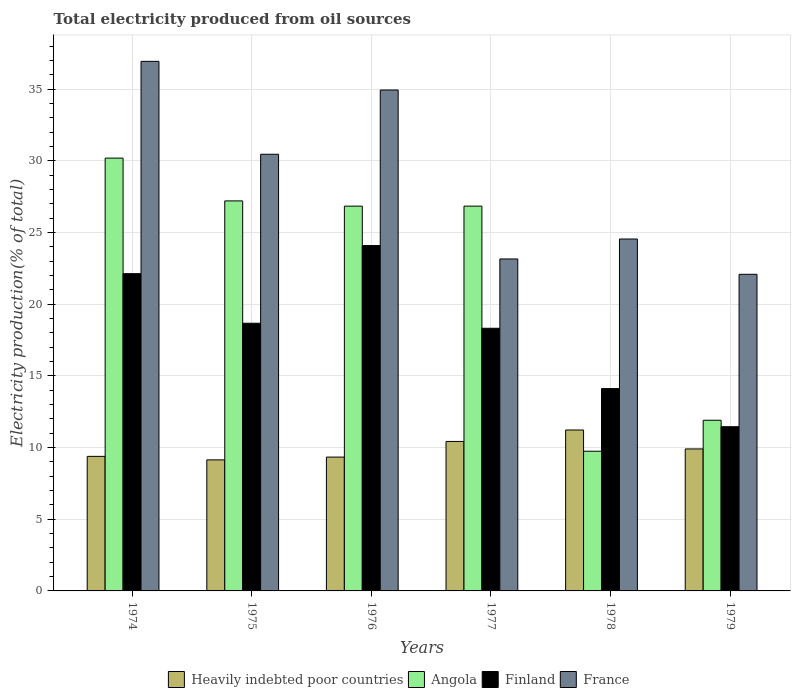Are the number of bars per tick equal to the number of legend labels?
Offer a very short reply. Yes. How many bars are there on the 3rd tick from the right?
Your response must be concise. 4. What is the label of the 2nd group of bars from the left?
Offer a terse response. 1975. In how many cases, is the number of bars for a given year not equal to the number of legend labels?
Make the answer very short. 0. What is the total electricity produced in Finland in 1979?
Give a very brief answer. 11.45. Across all years, what is the maximum total electricity produced in Angola?
Keep it short and to the point. 30.19. Across all years, what is the minimum total electricity produced in Angola?
Provide a short and direct response. 9.74. In which year was the total electricity produced in France maximum?
Your answer should be very brief. 1974. In which year was the total electricity produced in France minimum?
Offer a very short reply. 1979. What is the total total electricity produced in Heavily indebted poor countries in the graph?
Your response must be concise. 59.41. What is the difference between the total electricity produced in Heavily indebted poor countries in 1975 and that in 1978?
Provide a succinct answer. -2.09. What is the difference between the total electricity produced in Angola in 1974 and the total electricity produced in France in 1978?
Your response must be concise. 5.64. What is the average total electricity produced in Angola per year?
Keep it short and to the point. 22.12. In the year 1978, what is the difference between the total electricity produced in Finland and total electricity produced in Angola?
Provide a short and direct response. 4.37. What is the ratio of the total electricity produced in France in 1974 to that in 1977?
Your answer should be compact. 1.6. Is the total electricity produced in Angola in 1976 less than that in 1979?
Keep it short and to the point. No. What is the difference between the highest and the second highest total electricity produced in France?
Your answer should be very brief. 2. What is the difference between the highest and the lowest total electricity produced in Angola?
Provide a short and direct response. 20.44. In how many years, is the total electricity produced in Finland greater than the average total electricity produced in Finland taken over all years?
Provide a succinct answer. 4. Is the sum of the total electricity produced in Heavily indebted poor countries in 1977 and 1979 greater than the maximum total electricity produced in France across all years?
Give a very brief answer. No. Is it the case that in every year, the sum of the total electricity produced in Heavily indebted poor countries and total electricity produced in Angola is greater than the total electricity produced in Finland?
Provide a succinct answer. Yes. How many bars are there?
Provide a succinct answer. 24. How many years are there in the graph?
Keep it short and to the point. 6. What is the difference between two consecutive major ticks on the Y-axis?
Your answer should be very brief. 5. Are the values on the major ticks of Y-axis written in scientific E-notation?
Provide a succinct answer. No. Where does the legend appear in the graph?
Offer a terse response. Bottom center. What is the title of the graph?
Your answer should be compact. Total electricity produced from oil sources. Does "New Caledonia" appear as one of the legend labels in the graph?
Your answer should be compact. No. What is the label or title of the X-axis?
Your answer should be compact. Years. What is the Electricity production(% of total) in Heavily indebted poor countries in 1974?
Give a very brief answer. 9.38. What is the Electricity production(% of total) of Angola in 1974?
Your answer should be very brief. 30.19. What is the Electricity production(% of total) of Finland in 1974?
Your answer should be compact. 22.13. What is the Electricity production(% of total) of France in 1974?
Provide a short and direct response. 36.94. What is the Electricity production(% of total) in Heavily indebted poor countries in 1975?
Your answer should be very brief. 9.14. What is the Electricity production(% of total) of Angola in 1975?
Your answer should be compact. 27.2. What is the Electricity production(% of total) of Finland in 1975?
Ensure brevity in your answer.  18.67. What is the Electricity production(% of total) in France in 1975?
Provide a short and direct response. 30.46. What is the Electricity production(% of total) in Heavily indebted poor countries in 1976?
Offer a very short reply. 9.33. What is the Electricity production(% of total) of Angola in 1976?
Your answer should be compact. 26.84. What is the Electricity production(% of total) in Finland in 1976?
Offer a very short reply. 24.09. What is the Electricity production(% of total) of France in 1976?
Offer a terse response. 34.94. What is the Electricity production(% of total) in Heavily indebted poor countries in 1977?
Offer a very short reply. 10.43. What is the Electricity production(% of total) of Angola in 1977?
Offer a terse response. 26.84. What is the Electricity production(% of total) of Finland in 1977?
Your answer should be very brief. 18.32. What is the Electricity production(% of total) of France in 1977?
Give a very brief answer. 23.15. What is the Electricity production(% of total) in Heavily indebted poor countries in 1978?
Your answer should be very brief. 11.22. What is the Electricity production(% of total) in Angola in 1978?
Provide a succinct answer. 9.74. What is the Electricity production(% of total) of Finland in 1978?
Your answer should be compact. 14.11. What is the Electricity production(% of total) of France in 1978?
Provide a short and direct response. 24.54. What is the Electricity production(% of total) in Heavily indebted poor countries in 1979?
Ensure brevity in your answer.  9.9. What is the Electricity production(% of total) of Angola in 1979?
Keep it short and to the point. 11.9. What is the Electricity production(% of total) of Finland in 1979?
Your answer should be very brief. 11.45. What is the Electricity production(% of total) in France in 1979?
Offer a very short reply. 22.08. Across all years, what is the maximum Electricity production(% of total) in Heavily indebted poor countries?
Give a very brief answer. 11.22. Across all years, what is the maximum Electricity production(% of total) in Angola?
Provide a short and direct response. 30.19. Across all years, what is the maximum Electricity production(% of total) in Finland?
Provide a short and direct response. 24.09. Across all years, what is the maximum Electricity production(% of total) of France?
Provide a short and direct response. 36.94. Across all years, what is the minimum Electricity production(% of total) of Heavily indebted poor countries?
Your response must be concise. 9.14. Across all years, what is the minimum Electricity production(% of total) in Angola?
Offer a terse response. 9.74. Across all years, what is the minimum Electricity production(% of total) in Finland?
Your response must be concise. 11.45. Across all years, what is the minimum Electricity production(% of total) in France?
Provide a short and direct response. 22.08. What is the total Electricity production(% of total) in Heavily indebted poor countries in the graph?
Offer a very short reply. 59.41. What is the total Electricity production(% of total) of Angola in the graph?
Make the answer very short. 132.71. What is the total Electricity production(% of total) of Finland in the graph?
Provide a short and direct response. 108.77. What is the total Electricity production(% of total) of France in the graph?
Offer a terse response. 172.11. What is the difference between the Electricity production(% of total) of Heavily indebted poor countries in 1974 and that in 1975?
Offer a very short reply. 0.24. What is the difference between the Electricity production(% of total) in Angola in 1974 and that in 1975?
Keep it short and to the point. 2.98. What is the difference between the Electricity production(% of total) in Finland in 1974 and that in 1975?
Offer a very short reply. 3.46. What is the difference between the Electricity production(% of total) in France in 1974 and that in 1975?
Provide a succinct answer. 6.48. What is the difference between the Electricity production(% of total) in Heavily indebted poor countries in 1974 and that in 1976?
Your answer should be compact. 0.05. What is the difference between the Electricity production(% of total) in Angola in 1974 and that in 1976?
Offer a very short reply. 3.35. What is the difference between the Electricity production(% of total) of Finland in 1974 and that in 1976?
Offer a terse response. -1.96. What is the difference between the Electricity production(% of total) of France in 1974 and that in 1976?
Make the answer very short. 2. What is the difference between the Electricity production(% of total) in Heavily indebted poor countries in 1974 and that in 1977?
Offer a terse response. -1.04. What is the difference between the Electricity production(% of total) in Angola in 1974 and that in 1977?
Offer a terse response. 3.35. What is the difference between the Electricity production(% of total) in Finland in 1974 and that in 1977?
Give a very brief answer. 3.81. What is the difference between the Electricity production(% of total) of France in 1974 and that in 1977?
Your answer should be very brief. 13.78. What is the difference between the Electricity production(% of total) in Heavily indebted poor countries in 1974 and that in 1978?
Provide a short and direct response. -1.84. What is the difference between the Electricity production(% of total) in Angola in 1974 and that in 1978?
Give a very brief answer. 20.44. What is the difference between the Electricity production(% of total) of Finland in 1974 and that in 1978?
Provide a succinct answer. 8.02. What is the difference between the Electricity production(% of total) in France in 1974 and that in 1978?
Ensure brevity in your answer.  12.39. What is the difference between the Electricity production(% of total) of Heavily indebted poor countries in 1974 and that in 1979?
Your answer should be very brief. -0.52. What is the difference between the Electricity production(% of total) of Angola in 1974 and that in 1979?
Offer a very short reply. 18.28. What is the difference between the Electricity production(% of total) in Finland in 1974 and that in 1979?
Offer a very short reply. 10.67. What is the difference between the Electricity production(% of total) of France in 1974 and that in 1979?
Your response must be concise. 14.85. What is the difference between the Electricity production(% of total) of Heavily indebted poor countries in 1975 and that in 1976?
Provide a succinct answer. -0.2. What is the difference between the Electricity production(% of total) of Angola in 1975 and that in 1976?
Keep it short and to the point. 0.37. What is the difference between the Electricity production(% of total) of Finland in 1975 and that in 1976?
Ensure brevity in your answer.  -5.42. What is the difference between the Electricity production(% of total) in France in 1975 and that in 1976?
Your answer should be very brief. -4.48. What is the difference between the Electricity production(% of total) of Heavily indebted poor countries in 1975 and that in 1977?
Your answer should be compact. -1.29. What is the difference between the Electricity production(% of total) of Angola in 1975 and that in 1977?
Offer a very short reply. 0.37. What is the difference between the Electricity production(% of total) of Finland in 1975 and that in 1977?
Give a very brief answer. 0.35. What is the difference between the Electricity production(% of total) of France in 1975 and that in 1977?
Your response must be concise. 7.3. What is the difference between the Electricity production(% of total) of Heavily indebted poor countries in 1975 and that in 1978?
Provide a succinct answer. -2.09. What is the difference between the Electricity production(% of total) of Angola in 1975 and that in 1978?
Give a very brief answer. 17.46. What is the difference between the Electricity production(% of total) of Finland in 1975 and that in 1978?
Your answer should be very brief. 4.56. What is the difference between the Electricity production(% of total) in France in 1975 and that in 1978?
Offer a very short reply. 5.91. What is the difference between the Electricity production(% of total) of Heavily indebted poor countries in 1975 and that in 1979?
Offer a very short reply. -0.76. What is the difference between the Electricity production(% of total) in Angola in 1975 and that in 1979?
Provide a succinct answer. 15.3. What is the difference between the Electricity production(% of total) of Finland in 1975 and that in 1979?
Your answer should be very brief. 7.22. What is the difference between the Electricity production(% of total) of France in 1975 and that in 1979?
Offer a terse response. 8.37. What is the difference between the Electricity production(% of total) in Heavily indebted poor countries in 1976 and that in 1977?
Keep it short and to the point. -1.09. What is the difference between the Electricity production(% of total) of Angola in 1976 and that in 1977?
Provide a succinct answer. 0. What is the difference between the Electricity production(% of total) in Finland in 1976 and that in 1977?
Give a very brief answer. 5.77. What is the difference between the Electricity production(% of total) of France in 1976 and that in 1977?
Offer a terse response. 11.78. What is the difference between the Electricity production(% of total) in Heavily indebted poor countries in 1976 and that in 1978?
Your response must be concise. -1.89. What is the difference between the Electricity production(% of total) in Angola in 1976 and that in 1978?
Ensure brevity in your answer.  17.09. What is the difference between the Electricity production(% of total) in Finland in 1976 and that in 1978?
Keep it short and to the point. 9.98. What is the difference between the Electricity production(% of total) in France in 1976 and that in 1978?
Your answer should be very brief. 10.39. What is the difference between the Electricity production(% of total) in Heavily indebted poor countries in 1976 and that in 1979?
Provide a short and direct response. -0.57. What is the difference between the Electricity production(% of total) in Angola in 1976 and that in 1979?
Make the answer very short. 14.93. What is the difference between the Electricity production(% of total) in Finland in 1976 and that in 1979?
Your answer should be compact. 12.63. What is the difference between the Electricity production(% of total) of France in 1976 and that in 1979?
Make the answer very short. 12.85. What is the difference between the Electricity production(% of total) of Heavily indebted poor countries in 1977 and that in 1978?
Offer a terse response. -0.8. What is the difference between the Electricity production(% of total) in Angola in 1977 and that in 1978?
Give a very brief answer. 17.09. What is the difference between the Electricity production(% of total) in Finland in 1977 and that in 1978?
Offer a very short reply. 4.21. What is the difference between the Electricity production(% of total) in France in 1977 and that in 1978?
Your answer should be very brief. -1.39. What is the difference between the Electricity production(% of total) in Heavily indebted poor countries in 1977 and that in 1979?
Offer a terse response. 0.52. What is the difference between the Electricity production(% of total) in Angola in 1977 and that in 1979?
Make the answer very short. 14.93. What is the difference between the Electricity production(% of total) in Finland in 1977 and that in 1979?
Provide a succinct answer. 6.86. What is the difference between the Electricity production(% of total) of France in 1977 and that in 1979?
Give a very brief answer. 1.07. What is the difference between the Electricity production(% of total) in Heavily indebted poor countries in 1978 and that in 1979?
Offer a terse response. 1.32. What is the difference between the Electricity production(% of total) of Angola in 1978 and that in 1979?
Ensure brevity in your answer.  -2.16. What is the difference between the Electricity production(% of total) in Finland in 1978 and that in 1979?
Offer a very short reply. 2.66. What is the difference between the Electricity production(% of total) in France in 1978 and that in 1979?
Your answer should be compact. 2.46. What is the difference between the Electricity production(% of total) in Heavily indebted poor countries in 1974 and the Electricity production(% of total) in Angola in 1975?
Give a very brief answer. -17.82. What is the difference between the Electricity production(% of total) in Heavily indebted poor countries in 1974 and the Electricity production(% of total) in Finland in 1975?
Provide a succinct answer. -9.29. What is the difference between the Electricity production(% of total) of Heavily indebted poor countries in 1974 and the Electricity production(% of total) of France in 1975?
Offer a very short reply. -21.07. What is the difference between the Electricity production(% of total) of Angola in 1974 and the Electricity production(% of total) of Finland in 1975?
Offer a very short reply. 11.52. What is the difference between the Electricity production(% of total) in Angola in 1974 and the Electricity production(% of total) in France in 1975?
Make the answer very short. -0.27. What is the difference between the Electricity production(% of total) in Finland in 1974 and the Electricity production(% of total) in France in 1975?
Offer a very short reply. -8.33. What is the difference between the Electricity production(% of total) in Heavily indebted poor countries in 1974 and the Electricity production(% of total) in Angola in 1976?
Your answer should be very brief. -17.45. What is the difference between the Electricity production(% of total) of Heavily indebted poor countries in 1974 and the Electricity production(% of total) of Finland in 1976?
Your answer should be very brief. -14.7. What is the difference between the Electricity production(% of total) in Heavily indebted poor countries in 1974 and the Electricity production(% of total) in France in 1976?
Give a very brief answer. -25.55. What is the difference between the Electricity production(% of total) of Angola in 1974 and the Electricity production(% of total) of Finland in 1976?
Your answer should be compact. 6.1. What is the difference between the Electricity production(% of total) in Angola in 1974 and the Electricity production(% of total) in France in 1976?
Offer a very short reply. -4.75. What is the difference between the Electricity production(% of total) in Finland in 1974 and the Electricity production(% of total) in France in 1976?
Your response must be concise. -12.81. What is the difference between the Electricity production(% of total) in Heavily indebted poor countries in 1974 and the Electricity production(% of total) in Angola in 1977?
Your answer should be compact. -17.45. What is the difference between the Electricity production(% of total) in Heavily indebted poor countries in 1974 and the Electricity production(% of total) in Finland in 1977?
Offer a terse response. -8.93. What is the difference between the Electricity production(% of total) of Heavily indebted poor countries in 1974 and the Electricity production(% of total) of France in 1977?
Make the answer very short. -13.77. What is the difference between the Electricity production(% of total) in Angola in 1974 and the Electricity production(% of total) in Finland in 1977?
Your answer should be compact. 11.87. What is the difference between the Electricity production(% of total) in Angola in 1974 and the Electricity production(% of total) in France in 1977?
Your answer should be compact. 7.03. What is the difference between the Electricity production(% of total) of Finland in 1974 and the Electricity production(% of total) of France in 1977?
Offer a terse response. -1.03. What is the difference between the Electricity production(% of total) of Heavily indebted poor countries in 1974 and the Electricity production(% of total) of Angola in 1978?
Offer a terse response. -0.36. What is the difference between the Electricity production(% of total) of Heavily indebted poor countries in 1974 and the Electricity production(% of total) of Finland in 1978?
Keep it short and to the point. -4.73. What is the difference between the Electricity production(% of total) in Heavily indebted poor countries in 1974 and the Electricity production(% of total) in France in 1978?
Offer a very short reply. -15.16. What is the difference between the Electricity production(% of total) of Angola in 1974 and the Electricity production(% of total) of Finland in 1978?
Give a very brief answer. 16.08. What is the difference between the Electricity production(% of total) in Angola in 1974 and the Electricity production(% of total) in France in 1978?
Your answer should be compact. 5.64. What is the difference between the Electricity production(% of total) of Finland in 1974 and the Electricity production(% of total) of France in 1978?
Give a very brief answer. -2.42. What is the difference between the Electricity production(% of total) in Heavily indebted poor countries in 1974 and the Electricity production(% of total) in Angola in 1979?
Provide a succinct answer. -2.52. What is the difference between the Electricity production(% of total) of Heavily indebted poor countries in 1974 and the Electricity production(% of total) of Finland in 1979?
Your answer should be compact. -2.07. What is the difference between the Electricity production(% of total) in Heavily indebted poor countries in 1974 and the Electricity production(% of total) in France in 1979?
Give a very brief answer. -12.7. What is the difference between the Electricity production(% of total) of Angola in 1974 and the Electricity production(% of total) of Finland in 1979?
Provide a succinct answer. 18.73. What is the difference between the Electricity production(% of total) of Angola in 1974 and the Electricity production(% of total) of France in 1979?
Provide a short and direct response. 8.1. What is the difference between the Electricity production(% of total) of Finland in 1974 and the Electricity production(% of total) of France in 1979?
Offer a very short reply. 0.04. What is the difference between the Electricity production(% of total) of Heavily indebted poor countries in 1975 and the Electricity production(% of total) of Angola in 1976?
Your response must be concise. -17.7. What is the difference between the Electricity production(% of total) in Heavily indebted poor countries in 1975 and the Electricity production(% of total) in Finland in 1976?
Provide a succinct answer. -14.95. What is the difference between the Electricity production(% of total) of Heavily indebted poor countries in 1975 and the Electricity production(% of total) of France in 1976?
Your answer should be compact. -25.8. What is the difference between the Electricity production(% of total) in Angola in 1975 and the Electricity production(% of total) in Finland in 1976?
Offer a very short reply. 3.11. What is the difference between the Electricity production(% of total) in Angola in 1975 and the Electricity production(% of total) in France in 1976?
Ensure brevity in your answer.  -7.73. What is the difference between the Electricity production(% of total) in Finland in 1975 and the Electricity production(% of total) in France in 1976?
Make the answer very short. -16.27. What is the difference between the Electricity production(% of total) of Heavily indebted poor countries in 1975 and the Electricity production(% of total) of Angola in 1977?
Offer a terse response. -17.7. What is the difference between the Electricity production(% of total) of Heavily indebted poor countries in 1975 and the Electricity production(% of total) of Finland in 1977?
Offer a very short reply. -9.18. What is the difference between the Electricity production(% of total) of Heavily indebted poor countries in 1975 and the Electricity production(% of total) of France in 1977?
Give a very brief answer. -14.01. What is the difference between the Electricity production(% of total) in Angola in 1975 and the Electricity production(% of total) in Finland in 1977?
Provide a succinct answer. 8.88. What is the difference between the Electricity production(% of total) in Angola in 1975 and the Electricity production(% of total) in France in 1977?
Provide a short and direct response. 4.05. What is the difference between the Electricity production(% of total) in Finland in 1975 and the Electricity production(% of total) in France in 1977?
Your response must be concise. -4.48. What is the difference between the Electricity production(% of total) of Heavily indebted poor countries in 1975 and the Electricity production(% of total) of Angola in 1978?
Your response must be concise. -0.6. What is the difference between the Electricity production(% of total) in Heavily indebted poor countries in 1975 and the Electricity production(% of total) in Finland in 1978?
Your response must be concise. -4.97. What is the difference between the Electricity production(% of total) of Heavily indebted poor countries in 1975 and the Electricity production(% of total) of France in 1978?
Provide a succinct answer. -15.4. What is the difference between the Electricity production(% of total) in Angola in 1975 and the Electricity production(% of total) in Finland in 1978?
Your answer should be very brief. 13.09. What is the difference between the Electricity production(% of total) of Angola in 1975 and the Electricity production(% of total) of France in 1978?
Make the answer very short. 2.66. What is the difference between the Electricity production(% of total) of Finland in 1975 and the Electricity production(% of total) of France in 1978?
Offer a terse response. -5.87. What is the difference between the Electricity production(% of total) in Heavily indebted poor countries in 1975 and the Electricity production(% of total) in Angola in 1979?
Give a very brief answer. -2.77. What is the difference between the Electricity production(% of total) of Heavily indebted poor countries in 1975 and the Electricity production(% of total) of Finland in 1979?
Keep it short and to the point. -2.31. What is the difference between the Electricity production(% of total) in Heavily indebted poor countries in 1975 and the Electricity production(% of total) in France in 1979?
Your response must be concise. -12.94. What is the difference between the Electricity production(% of total) in Angola in 1975 and the Electricity production(% of total) in Finland in 1979?
Keep it short and to the point. 15.75. What is the difference between the Electricity production(% of total) in Angola in 1975 and the Electricity production(% of total) in France in 1979?
Make the answer very short. 5.12. What is the difference between the Electricity production(% of total) in Finland in 1975 and the Electricity production(% of total) in France in 1979?
Offer a terse response. -3.41. What is the difference between the Electricity production(% of total) of Heavily indebted poor countries in 1976 and the Electricity production(% of total) of Angola in 1977?
Provide a succinct answer. -17.5. What is the difference between the Electricity production(% of total) of Heavily indebted poor countries in 1976 and the Electricity production(% of total) of Finland in 1977?
Offer a very short reply. -8.98. What is the difference between the Electricity production(% of total) of Heavily indebted poor countries in 1976 and the Electricity production(% of total) of France in 1977?
Your answer should be very brief. -13.82. What is the difference between the Electricity production(% of total) in Angola in 1976 and the Electricity production(% of total) in Finland in 1977?
Offer a very short reply. 8.52. What is the difference between the Electricity production(% of total) of Angola in 1976 and the Electricity production(% of total) of France in 1977?
Your response must be concise. 3.68. What is the difference between the Electricity production(% of total) in Finland in 1976 and the Electricity production(% of total) in France in 1977?
Your answer should be very brief. 0.93. What is the difference between the Electricity production(% of total) in Heavily indebted poor countries in 1976 and the Electricity production(% of total) in Angola in 1978?
Your answer should be compact. -0.41. What is the difference between the Electricity production(% of total) in Heavily indebted poor countries in 1976 and the Electricity production(% of total) in Finland in 1978?
Provide a short and direct response. -4.78. What is the difference between the Electricity production(% of total) of Heavily indebted poor countries in 1976 and the Electricity production(% of total) of France in 1978?
Keep it short and to the point. -15.21. What is the difference between the Electricity production(% of total) of Angola in 1976 and the Electricity production(% of total) of Finland in 1978?
Provide a short and direct response. 12.73. What is the difference between the Electricity production(% of total) of Angola in 1976 and the Electricity production(% of total) of France in 1978?
Give a very brief answer. 2.29. What is the difference between the Electricity production(% of total) of Finland in 1976 and the Electricity production(% of total) of France in 1978?
Your answer should be very brief. -0.46. What is the difference between the Electricity production(% of total) in Heavily indebted poor countries in 1976 and the Electricity production(% of total) in Angola in 1979?
Keep it short and to the point. -2.57. What is the difference between the Electricity production(% of total) of Heavily indebted poor countries in 1976 and the Electricity production(% of total) of Finland in 1979?
Provide a succinct answer. -2.12. What is the difference between the Electricity production(% of total) of Heavily indebted poor countries in 1976 and the Electricity production(% of total) of France in 1979?
Offer a terse response. -12.75. What is the difference between the Electricity production(% of total) in Angola in 1976 and the Electricity production(% of total) in Finland in 1979?
Your response must be concise. 15.38. What is the difference between the Electricity production(% of total) of Angola in 1976 and the Electricity production(% of total) of France in 1979?
Provide a short and direct response. 4.75. What is the difference between the Electricity production(% of total) of Finland in 1976 and the Electricity production(% of total) of France in 1979?
Offer a terse response. 2.01. What is the difference between the Electricity production(% of total) of Heavily indebted poor countries in 1977 and the Electricity production(% of total) of Angola in 1978?
Your answer should be compact. 0.68. What is the difference between the Electricity production(% of total) in Heavily indebted poor countries in 1977 and the Electricity production(% of total) in Finland in 1978?
Your answer should be compact. -3.69. What is the difference between the Electricity production(% of total) in Heavily indebted poor countries in 1977 and the Electricity production(% of total) in France in 1978?
Your answer should be very brief. -14.12. What is the difference between the Electricity production(% of total) in Angola in 1977 and the Electricity production(% of total) in Finland in 1978?
Provide a succinct answer. 12.73. What is the difference between the Electricity production(% of total) in Angola in 1977 and the Electricity production(% of total) in France in 1978?
Provide a succinct answer. 2.29. What is the difference between the Electricity production(% of total) of Finland in 1977 and the Electricity production(% of total) of France in 1978?
Keep it short and to the point. -6.23. What is the difference between the Electricity production(% of total) of Heavily indebted poor countries in 1977 and the Electricity production(% of total) of Angola in 1979?
Give a very brief answer. -1.48. What is the difference between the Electricity production(% of total) of Heavily indebted poor countries in 1977 and the Electricity production(% of total) of Finland in 1979?
Provide a succinct answer. -1.03. What is the difference between the Electricity production(% of total) in Heavily indebted poor countries in 1977 and the Electricity production(% of total) in France in 1979?
Your answer should be compact. -11.66. What is the difference between the Electricity production(% of total) in Angola in 1977 and the Electricity production(% of total) in Finland in 1979?
Give a very brief answer. 15.38. What is the difference between the Electricity production(% of total) of Angola in 1977 and the Electricity production(% of total) of France in 1979?
Make the answer very short. 4.75. What is the difference between the Electricity production(% of total) in Finland in 1977 and the Electricity production(% of total) in France in 1979?
Give a very brief answer. -3.76. What is the difference between the Electricity production(% of total) of Heavily indebted poor countries in 1978 and the Electricity production(% of total) of Angola in 1979?
Provide a succinct answer. -0.68. What is the difference between the Electricity production(% of total) in Heavily indebted poor countries in 1978 and the Electricity production(% of total) in Finland in 1979?
Offer a very short reply. -0.23. What is the difference between the Electricity production(% of total) in Heavily indebted poor countries in 1978 and the Electricity production(% of total) in France in 1979?
Keep it short and to the point. -10.86. What is the difference between the Electricity production(% of total) in Angola in 1978 and the Electricity production(% of total) in Finland in 1979?
Make the answer very short. -1.71. What is the difference between the Electricity production(% of total) of Angola in 1978 and the Electricity production(% of total) of France in 1979?
Provide a short and direct response. -12.34. What is the difference between the Electricity production(% of total) of Finland in 1978 and the Electricity production(% of total) of France in 1979?
Offer a very short reply. -7.97. What is the average Electricity production(% of total) in Heavily indebted poor countries per year?
Give a very brief answer. 9.9. What is the average Electricity production(% of total) in Angola per year?
Your response must be concise. 22.12. What is the average Electricity production(% of total) of Finland per year?
Give a very brief answer. 18.13. What is the average Electricity production(% of total) in France per year?
Your answer should be compact. 28.68. In the year 1974, what is the difference between the Electricity production(% of total) in Heavily indebted poor countries and Electricity production(% of total) in Angola?
Your response must be concise. -20.8. In the year 1974, what is the difference between the Electricity production(% of total) of Heavily indebted poor countries and Electricity production(% of total) of Finland?
Provide a short and direct response. -12.74. In the year 1974, what is the difference between the Electricity production(% of total) of Heavily indebted poor countries and Electricity production(% of total) of France?
Your answer should be compact. -27.55. In the year 1974, what is the difference between the Electricity production(% of total) of Angola and Electricity production(% of total) of Finland?
Keep it short and to the point. 8.06. In the year 1974, what is the difference between the Electricity production(% of total) of Angola and Electricity production(% of total) of France?
Give a very brief answer. -6.75. In the year 1974, what is the difference between the Electricity production(% of total) of Finland and Electricity production(% of total) of France?
Offer a terse response. -14.81. In the year 1975, what is the difference between the Electricity production(% of total) of Heavily indebted poor countries and Electricity production(% of total) of Angola?
Make the answer very short. -18.06. In the year 1975, what is the difference between the Electricity production(% of total) of Heavily indebted poor countries and Electricity production(% of total) of Finland?
Offer a terse response. -9.53. In the year 1975, what is the difference between the Electricity production(% of total) in Heavily indebted poor countries and Electricity production(% of total) in France?
Offer a very short reply. -21.32. In the year 1975, what is the difference between the Electricity production(% of total) in Angola and Electricity production(% of total) in Finland?
Your answer should be compact. 8.53. In the year 1975, what is the difference between the Electricity production(% of total) in Angola and Electricity production(% of total) in France?
Your answer should be very brief. -3.25. In the year 1975, what is the difference between the Electricity production(% of total) in Finland and Electricity production(% of total) in France?
Your answer should be compact. -11.79. In the year 1976, what is the difference between the Electricity production(% of total) of Heavily indebted poor countries and Electricity production(% of total) of Angola?
Provide a succinct answer. -17.5. In the year 1976, what is the difference between the Electricity production(% of total) in Heavily indebted poor countries and Electricity production(% of total) in Finland?
Your answer should be compact. -14.75. In the year 1976, what is the difference between the Electricity production(% of total) of Heavily indebted poor countries and Electricity production(% of total) of France?
Your response must be concise. -25.6. In the year 1976, what is the difference between the Electricity production(% of total) of Angola and Electricity production(% of total) of Finland?
Give a very brief answer. 2.75. In the year 1976, what is the difference between the Electricity production(% of total) in Angola and Electricity production(% of total) in France?
Give a very brief answer. -8.1. In the year 1976, what is the difference between the Electricity production(% of total) in Finland and Electricity production(% of total) in France?
Provide a succinct answer. -10.85. In the year 1977, what is the difference between the Electricity production(% of total) of Heavily indebted poor countries and Electricity production(% of total) of Angola?
Give a very brief answer. -16.41. In the year 1977, what is the difference between the Electricity production(% of total) in Heavily indebted poor countries and Electricity production(% of total) in Finland?
Provide a succinct answer. -7.89. In the year 1977, what is the difference between the Electricity production(% of total) in Heavily indebted poor countries and Electricity production(% of total) in France?
Ensure brevity in your answer.  -12.73. In the year 1977, what is the difference between the Electricity production(% of total) in Angola and Electricity production(% of total) in Finland?
Offer a very short reply. 8.52. In the year 1977, what is the difference between the Electricity production(% of total) of Angola and Electricity production(% of total) of France?
Offer a terse response. 3.68. In the year 1977, what is the difference between the Electricity production(% of total) of Finland and Electricity production(% of total) of France?
Your answer should be very brief. -4.83. In the year 1978, what is the difference between the Electricity production(% of total) of Heavily indebted poor countries and Electricity production(% of total) of Angola?
Your answer should be compact. 1.48. In the year 1978, what is the difference between the Electricity production(% of total) in Heavily indebted poor countries and Electricity production(% of total) in Finland?
Your answer should be compact. -2.89. In the year 1978, what is the difference between the Electricity production(% of total) of Heavily indebted poor countries and Electricity production(% of total) of France?
Your answer should be very brief. -13.32. In the year 1978, what is the difference between the Electricity production(% of total) of Angola and Electricity production(% of total) of Finland?
Make the answer very short. -4.37. In the year 1978, what is the difference between the Electricity production(% of total) in Angola and Electricity production(% of total) in France?
Ensure brevity in your answer.  -14.8. In the year 1978, what is the difference between the Electricity production(% of total) of Finland and Electricity production(% of total) of France?
Give a very brief answer. -10.43. In the year 1979, what is the difference between the Electricity production(% of total) of Heavily indebted poor countries and Electricity production(% of total) of Angola?
Your answer should be very brief. -2. In the year 1979, what is the difference between the Electricity production(% of total) in Heavily indebted poor countries and Electricity production(% of total) in Finland?
Your answer should be compact. -1.55. In the year 1979, what is the difference between the Electricity production(% of total) of Heavily indebted poor countries and Electricity production(% of total) of France?
Provide a short and direct response. -12.18. In the year 1979, what is the difference between the Electricity production(% of total) in Angola and Electricity production(% of total) in Finland?
Offer a very short reply. 0.45. In the year 1979, what is the difference between the Electricity production(% of total) of Angola and Electricity production(% of total) of France?
Provide a succinct answer. -10.18. In the year 1979, what is the difference between the Electricity production(% of total) in Finland and Electricity production(% of total) in France?
Your answer should be compact. -10.63. What is the ratio of the Electricity production(% of total) of Heavily indebted poor countries in 1974 to that in 1975?
Your answer should be compact. 1.03. What is the ratio of the Electricity production(% of total) in Angola in 1974 to that in 1975?
Keep it short and to the point. 1.11. What is the ratio of the Electricity production(% of total) in Finland in 1974 to that in 1975?
Keep it short and to the point. 1.19. What is the ratio of the Electricity production(% of total) in France in 1974 to that in 1975?
Your answer should be very brief. 1.21. What is the ratio of the Electricity production(% of total) of Angola in 1974 to that in 1976?
Give a very brief answer. 1.12. What is the ratio of the Electricity production(% of total) of Finland in 1974 to that in 1976?
Give a very brief answer. 0.92. What is the ratio of the Electricity production(% of total) in France in 1974 to that in 1976?
Offer a very short reply. 1.06. What is the ratio of the Electricity production(% of total) of Heavily indebted poor countries in 1974 to that in 1977?
Your response must be concise. 0.9. What is the ratio of the Electricity production(% of total) in Angola in 1974 to that in 1977?
Provide a short and direct response. 1.12. What is the ratio of the Electricity production(% of total) in Finland in 1974 to that in 1977?
Your answer should be very brief. 1.21. What is the ratio of the Electricity production(% of total) of France in 1974 to that in 1977?
Provide a short and direct response. 1.6. What is the ratio of the Electricity production(% of total) in Heavily indebted poor countries in 1974 to that in 1978?
Provide a short and direct response. 0.84. What is the ratio of the Electricity production(% of total) of Angola in 1974 to that in 1978?
Give a very brief answer. 3.1. What is the ratio of the Electricity production(% of total) in Finland in 1974 to that in 1978?
Your response must be concise. 1.57. What is the ratio of the Electricity production(% of total) in France in 1974 to that in 1978?
Keep it short and to the point. 1.5. What is the ratio of the Electricity production(% of total) in Heavily indebted poor countries in 1974 to that in 1979?
Your response must be concise. 0.95. What is the ratio of the Electricity production(% of total) in Angola in 1974 to that in 1979?
Your answer should be compact. 2.54. What is the ratio of the Electricity production(% of total) of Finland in 1974 to that in 1979?
Your answer should be very brief. 1.93. What is the ratio of the Electricity production(% of total) of France in 1974 to that in 1979?
Provide a short and direct response. 1.67. What is the ratio of the Electricity production(% of total) in Heavily indebted poor countries in 1975 to that in 1976?
Keep it short and to the point. 0.98. What is the ratio of the Electricity production(% of total) in Angola in 1975 to that in 1976?
Provide a succinct answer. 1.01. What is the ratio of the Electricity production(% of total) of Finland in 1975 to that in 1976?
Your answer should be very brief. 0.78. What is the ratio of the Electricity production(% of total) in France in 1975 to that in 1976?
Make the answer very short. 0.87. What is the ratio of the Electricity production(% of total) of Heavily indebted poor countries in 1975 to that in 1977?
Provide a succinct answer. 0.88. What is the ratio of the Electricity production(% of total) in Angola in 1975 to that in 1977?
Your answer should be compact. 1.01. What is the ratio of the Electricity production(% of total) in Finland in 1975 to that in 1977?
Keep it short and to the point. 1.02. What is the ratio of the Electricity production(% of total) in France in 1975 to that in 1977?
Provide a short and direct response. 1.32. What is the ratio of the Electricity production(% of total) of Heavily indebted poor countries in 1975 to that in 1978?
Offer a very short reply. 0.81. What is the ratio of the Electricity production(% of total) in Angola in 1975 to that in 1978?
Your response must be concise. 2.79. What is the ratio of the Electricity production(% of total) in Finland in 1975 to that in 1978?
Keep it short and to the point. 1.32. What is the ratio of the Electricity production(% of total) of France in 1975 to that in 1978?
Ensure brevity in your answer.  1.24. What is the ratio of the Electricity production(% of total) of Heavily indebted poor countries in 1975 to that in 1979?
Make the answer very short. 0.92. What is the ratio of the Electricity production(% of total) of Angola in 1975 to that in 1979?
Ensure brevity in your answer.  2.29. What is the ratio of the Electricity production(% of total) in Finland in 1975 to that in 1979?
Offer a very short reply. 1.63. What is the ratio of the Electricity production(% of total) of France in 1975 to that in 1979?
Your answer should be compact. 1.38. What is the ratio of the Electricity production(% of total) in Heavily indebted poor countries in 1976 to that in 1977?
Your answer should be very brief. 0.9. What is the ratio of the Electricity production(% of total) in Angola in 1976 to that in 1977?
Provide a short and direct response. 1. What is the ratio of the Electricity production(% of total) in Finland in 1976 to that in 1977?
Keep it short and to the point. 1.31. What is the ratio of the Electricity production(% of total) in France in 1976 to that in 1977?
Make the answer very short. 1.51. What is the ratio of the Electricity production(% of total) in Heavily indebted poor countries in 1976 to that in 1978?
Give a very brief answer. 0.83. What is the ratio of the Electricity production(% of total) of Angola in 1976 to that in 1978?
Offer a very short reply. 2.75. What is the ratio of the Electricity production(% of total) in Finland in 1976 to that in 1978?
Provide a succinct answer. 1.71. What is the ratio of the Electricity production(% of total) in France in 1976 to that in 1978?
Offer a terse response. 1.42. What is the ratio of the Electricity production(% of total) of Heavily indebted poor countries in 1976 to that in 1979?
Your answer should be compact. 0.94. What is the ratio of the Electricity production(% of total) of Angola in 1976 to that in 1979?
Give a very brief answer. 2.25. What is the ratio of the Electricity production(% of total) of Finland in 1976 to that in 1979?
Offer a very short reply. 2.1. What is the ratio of the Electricity production(% of total) of France in 1976 to that in 1979?
Provide a short and direct response. 1.58. What is the ratio of the Electricity production(% of total) in Heavily indebted poor countries in 1977 to that in 1978?
Offer a terse response. 0.93. What is the ratio of the Electricity production(% of total) of Angola in 1977 to that in 1978?
Ensure brevity in your answer.  2.75. What is the ratio of the Electricity production(% of total) of Finland in 1977 to that in 1978?
Your answer should be very brief. 1.3. What is the ratio of the Electricity production(% of total) in France in 1977 to that in 1978?
Provide a succinct answer. 0.94. What is the ratio of the Electricity production(% of total) of Heavily indebted poor countries in 1977 to that in 1979?
Offer a terse response. 1.05. What is the ratio of the Electricity production(% of total) of Angola in 1977 to that in 1979?
Offer a terse response. 2.25. What is the ratio of the Electricity production(% of total) in Finland in 1977 to that in 1979?
Make the answer very short. 1.6. What is the ratio of the Electricity production(% of total) of France in 1977 to that in 1979?
Give a very brief answer. 1.05. What is the ratio of the Electricity production(% of total) in Heavily indebted poor countries in 1978 to that in 1979?
Offer a terse response. 1.13. What is the ratio of the Electricity production(% of total) in Angola in 1978 to that in 1979?
Provide a succinct answer. 0.82. What is the ratio of the Electricity production(% of total) of Finland in 1978 to that in 1979?
Make the answer very short. 1.23. What is the ratio of the Electricity production(% of total) in France in 1978 to that in 1979?
Keep it short and to the point. 1.11. What is the difference between the highest and the second highest Electricity production(% of total) in Heavily indebted poor countries?
Your answer should be very brief. 0.8. What is the difference between the highest and the second highest Electricity production(% of total) in Angola?
Provide a short and direct response. 2.98. What is the difference between the highest and the second highest Electricity production(% of total) of Finland?
Your answer should be compact. 1.96. What is the difference between the highest and the second highest Electricity production(% of total) of France?
Provide a short and direct response. 2. What is the difference between the highest and the lowest Electricity production(% of total) in Heavily indebted poor countries?
Provide a short and direct response. 2.09. What is the difference between the highest and the lowest Electricity production(% of total) of Angola?
Your answer should be very brief. 20.44. What is the difference between the highest and the lowest Electricity production(% of total) of Finland?
Your response must be concise. 12.63. What is the difference between the highest and the lowest Electricity production(% of total) of France?
Your answer should be very brief. 14.85. 